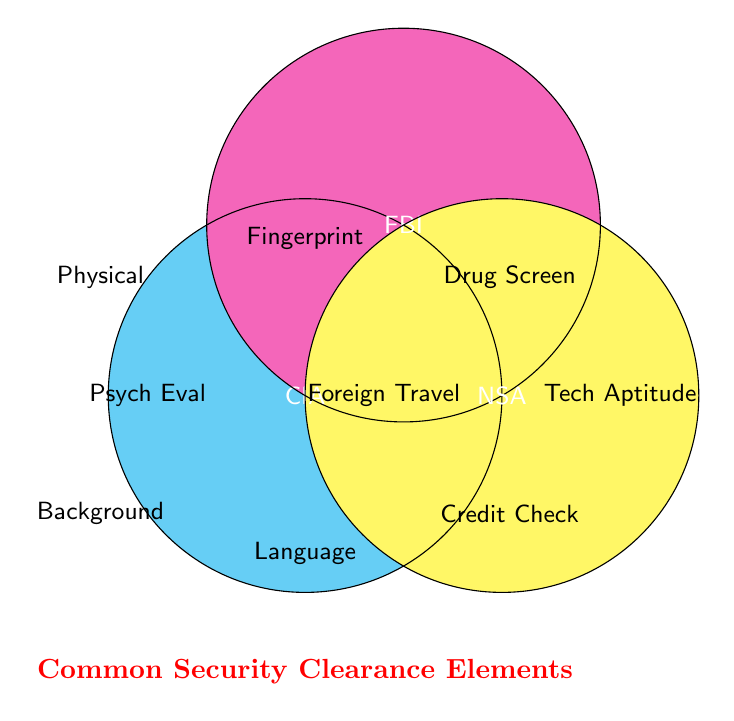What is the title of the Venn Diagram? The title of the Venn Diagram can be identified by looking at the text positioned outside and below the three intersecting circles. It is typically in a different color or font to make it stand out.
Answer: Common Security Clearance Elements Which agency requires a language proficiency test for Secret clearance? The agency requiring language proficiency for Secret clearance can be identified by locating the text "Language" within the circle labeled "CIA."
Answer: CIA How many elements are common to all three agencies for Top Secret clearance? To determine the number of elements common to all three agencies for Top Secret clearance, look for the text positioned at the intersection of all three circles.
Answer: One element: Fingerprinting Which agencies require a credit check for Top Secret clearance? Agencies that require a credit check can be identified by looking at the text "Credit Check" and noting its position within the intersecting area of the circles labeled "CIA" and "FBI."
Answer: CIA and FBI What security clearance level is associated with a technical aptitude test? The security clearance associated with a technical aptitude test can be identified by locating the text "Tech Aptitude" and observing its position within or outside the circles.
Answer: Secret What is the only element required by the NSA for Secret clearance that is not shared with any other agency? To find this element, locate the text within the NSA circle that does not intersect with any other circles and is labeled as for Secret clearance.
Answer: Technical Aptitude Test Identify the element that is common between FBI and NSA for Top Secret clearance. The common element for Top Secret clearance between FBI and NSA can be found by looking at the overlapping region of the circles labeled "FBI" and "NSA."
Answer: Drug Screening Which agencies require a psychological evaluation for Top Secret clearance? The agencies listed with a psychological evaluation requirement can be identified by finding the text "Psych Eval" and noting its position within the appropriate circle(s).
Answer: NSA Which agency requires a physical fitness test for Secret clearance? The agency with this requirement can be identified by locating the text "Physical" within the appropriate circle.
Answer: FBI 